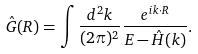<formula> <loc_0><loc_0><loc_500><loc_500>\hat { G } ( { R } ) = \int \frac { d ^ { 2 } { k } } { ( 2 \pi ) ^ { 2 } } \frac { e ^ { i { k } \cdot { R } } } { E - \hat { H } ( { k } ) } .</formula> 